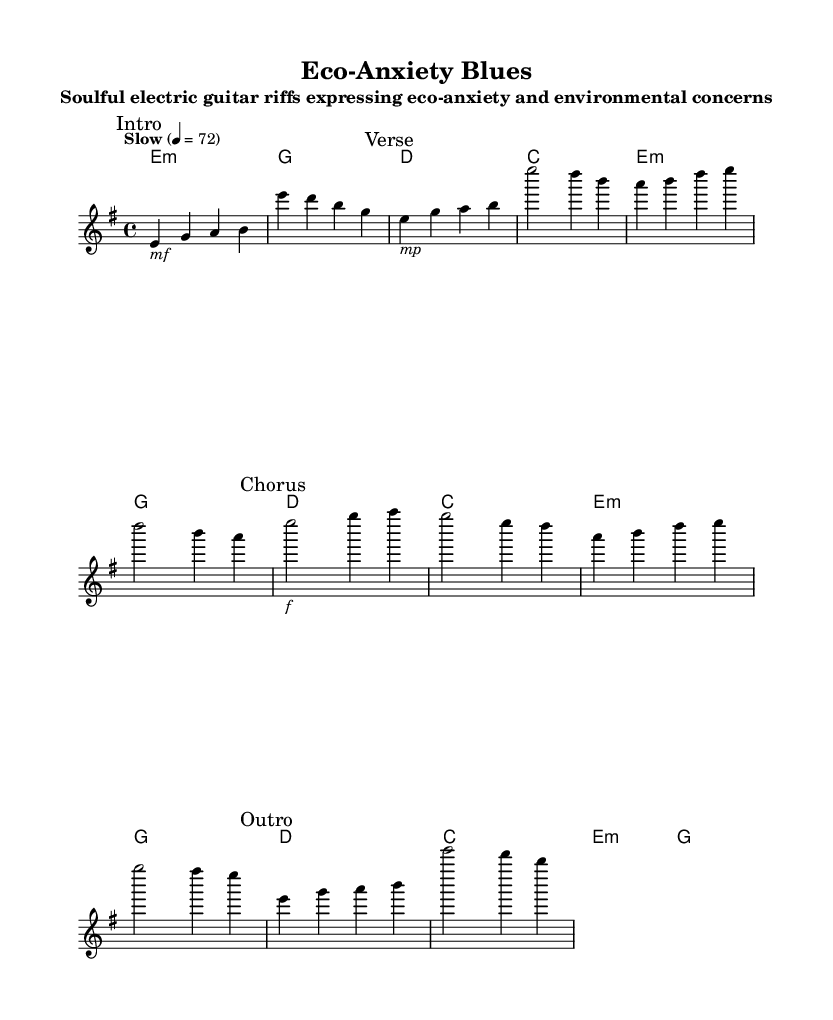What is the key signature of this music? The key signature is E minor, which has one sharp (F#).
Answer: E minor What is the time signature of this piece? The time signature is indicated as 4/4, meaning there are four beats per measure.
Answer: 4/4 What does the tempo marking indicate? The tempo marking "Slow" at 4 equals 72 suggests a relaxed pace, typically around 72 beats per minute.
Answer: Slow, 72 How many sections are there in this piece? The music includes four distinct sections, which are the Intro, Verse, Chorus, and Outro.
Answer: Four What type of guitar is indicated for this piece? The score specifies an "electric guitar" as the intended instrument for performance.
Answer: Electric guitar What is the main emotion expressed in the title of the piece? The title "Eco-Anxiety Blues" suggests that the music expresses feelings related to environmental concerns and anxiety.
Answer: Eco-anxiety Which section contains a forte dynamic marking? The Chorus section is marked with "f," denoting a forte dynamic, indicating a strong and loud expression.
Answer: Chorus 